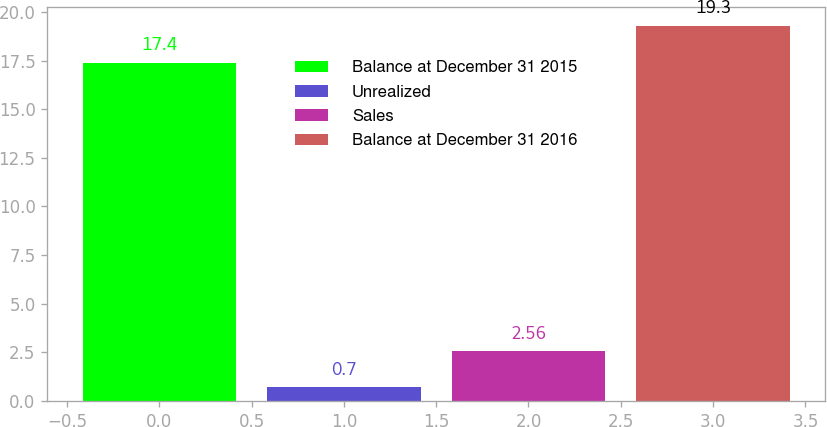<chart> <loc_0><loc_0><loc_500><loc_500><bar_chart><fcel>Balance at December 31 2015<fcel>Unrealized<fcel>Sales<fcel>Balance at December 31 2016<nl><fcel>17.4<fcel>0.7<fcel>2.56<fcel>19.3<nl></chart> 